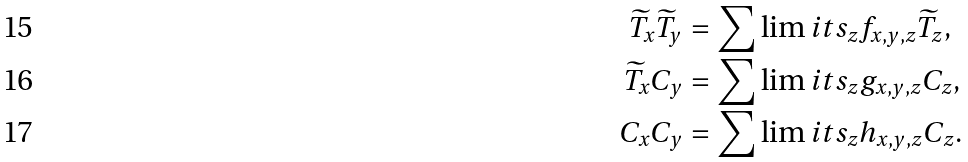Convert formula to latex. <formula><loc_0><loc_0><loc_500><loc_500>\widetilde { T } _ { x } \widetilde { T } _ { y } & = \sum \lim i t s _ { z } f _ { x , y , z } \widetilde { T } _ { z } , \\ \widetilde { T } _ { x } C _ { y } & = \sum \lim i t s _ { z } g _ { x , y , z } C _ { z } , \\ C _ { x } C _ { y } & = \sum \lim i t s _ { z } h _ { x , y , z } C _ { z } .</formula> 